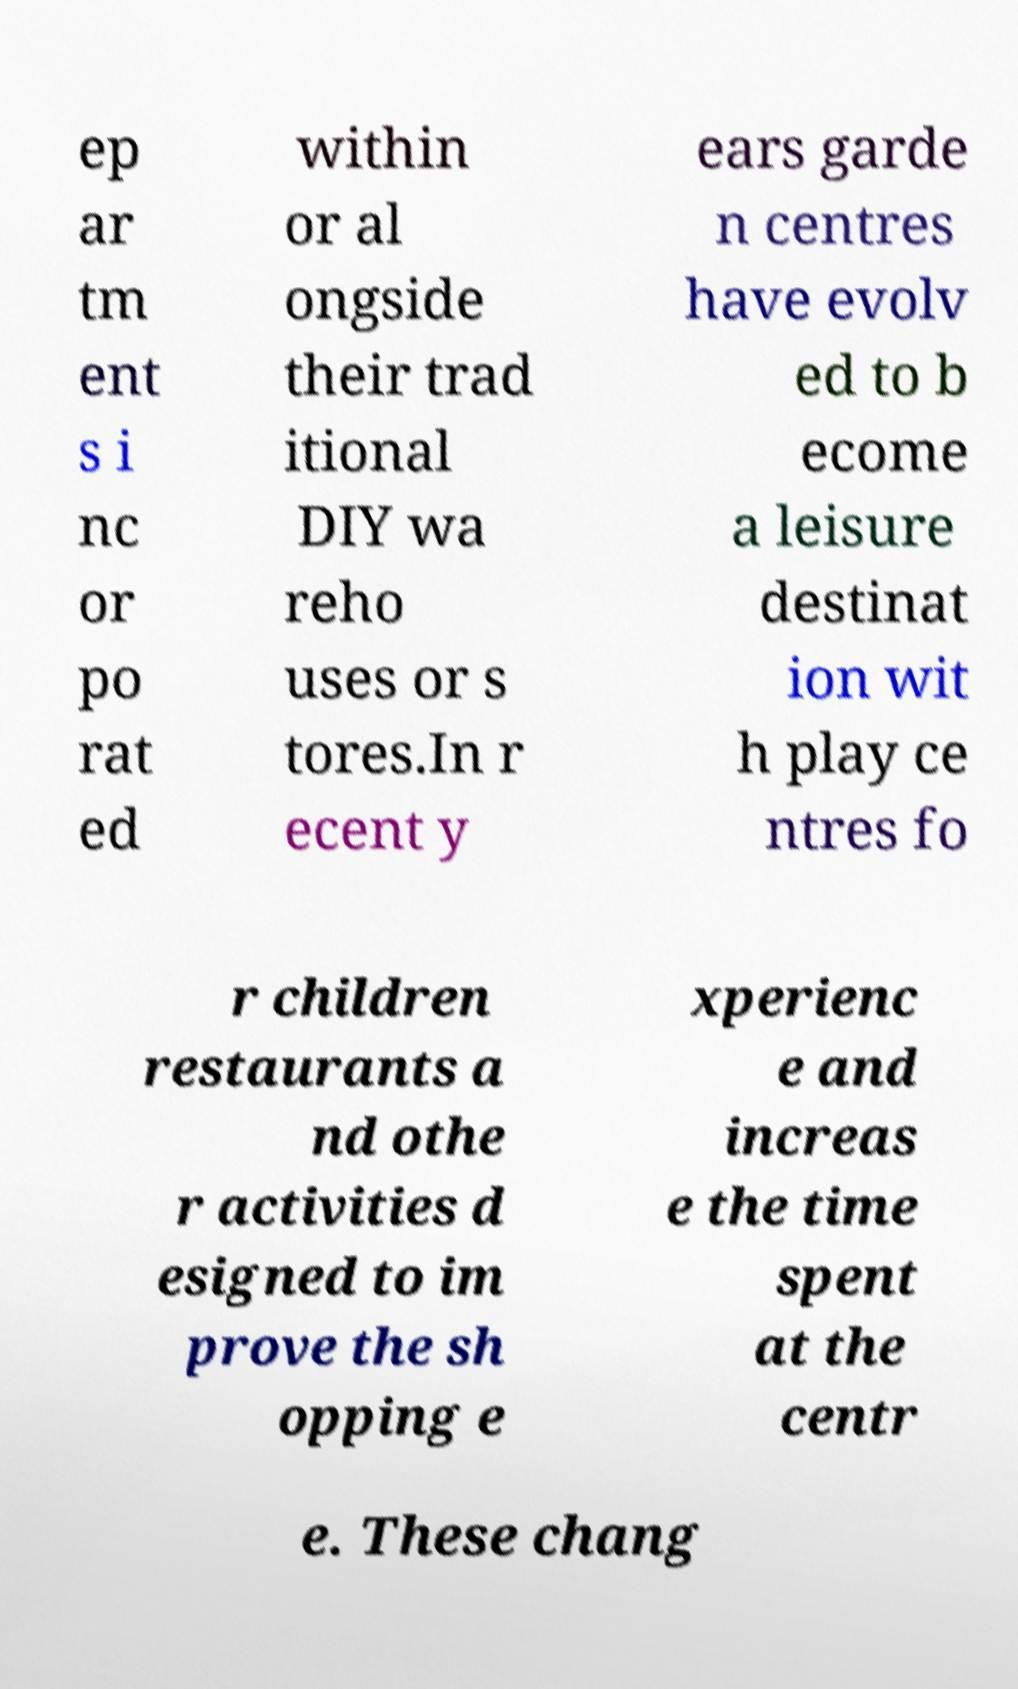I need the written content from this picture converted into text. Can you do that? ep ar tm ent s i nc or po rat ed within or al ongside their trad itional DIY wa reho uses or s tores.In r ecent y ears garde n centres have evolv ed to b ecome a leisure destinat ion wit h play ce ntres fo r children restaurants a nd othe r activities d esigned to im prove the sh opping e xperienc e and increas e the time spent at the centr e. These chang 